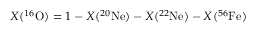Convert formula to latex. <formula><loc_0><loc_0><loc_500><loc_500>X ( ^ { 1 6 } O ) = 1 - X ( ^ { 2 0 } N e ) - X ( ^ { 2 2 } N e ) - X ( ^ { 5 6 } F e )</formula> 